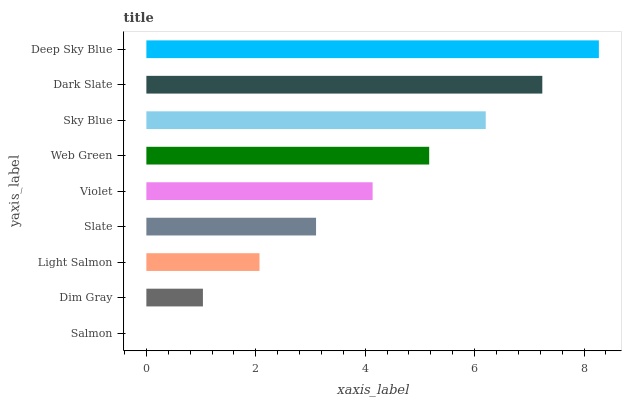Is Salmon the minimum?
Answer yes or no. Yes. Is Deep Sky Blue the maximum?
Answer yes or no. Yes. Is Dim Gray the minimum?
Answer yes or no. No. Is Dim Gray the maximum?
Answer yes or no. No. Is Dim Gray greater than Salmon?
Answer yes or no. Yes. Is Salmon less than Dim Gray?
Answer yes or no. Yes. Is Salmon greater than Dim Gray?
Answer yes or no. No. Is Dim Gray less than Salmon?
Answer yes or no. No. Is Violet the high median?
Answer yes or no. Yes. Is Violet the low median?
Answer yes or no. Yes. Is Deep Sky Blue the high median?
Answer yes or no. No. Is Dark Slate the low median?
Answer yes or no. No. 